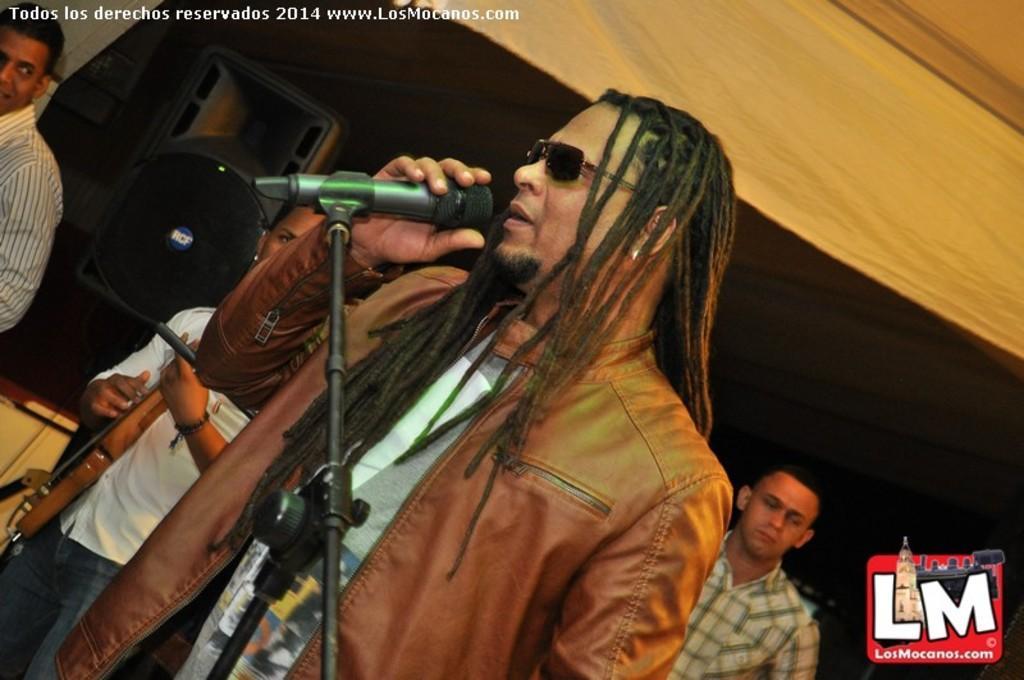Can you describe this image briefly? Here we can see a man standing in the center. He is wearing a coat and he is speaking on a microphone. In the background we can observe three persons and a speaker which is on the top left. 